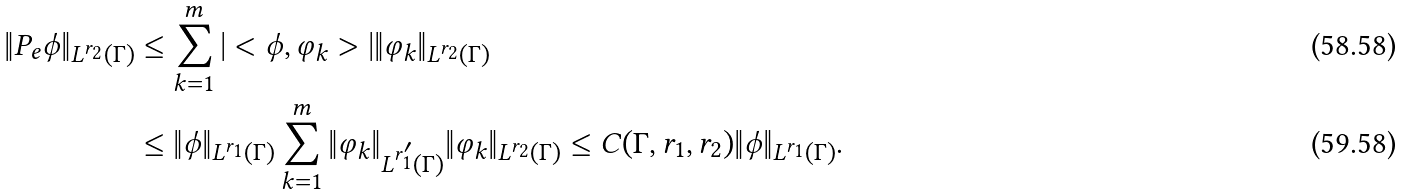Convert formula to latex. <formula><loc_0><loc_0><loc_500><loc_500>\| P _ { e } \phi \| _ { L ^ { r _ { 2 } } ( \Gamma ) } & \leq \sum _ { k = 1 } ^ { m } | < \phi , \varphi _ { k } > | \| \varphi _ { k } \| _ { L ^ { r _ { 2 } } ( \Gamma ) } \\ & \leq \| \phi \| _ { L ^ { r _ { 1 } } ( \Gamma ) } \sum _ { k = 1 } ^ { m } \| \varphi _ { k } \| _ { L ^ { r _ { 1 } ^ { \prime } } ( \Gamma ) } \| \varphi _ { k } \| _ { L ^ { r _ { 2 } } ( \Gamma ) } \leq C ( \Gamma , r _ { 1 } , r _ { 2 } ) \| \phi \| _ { L ^ { r _ { 1 } } ( \Gamma ) } .</formula> 